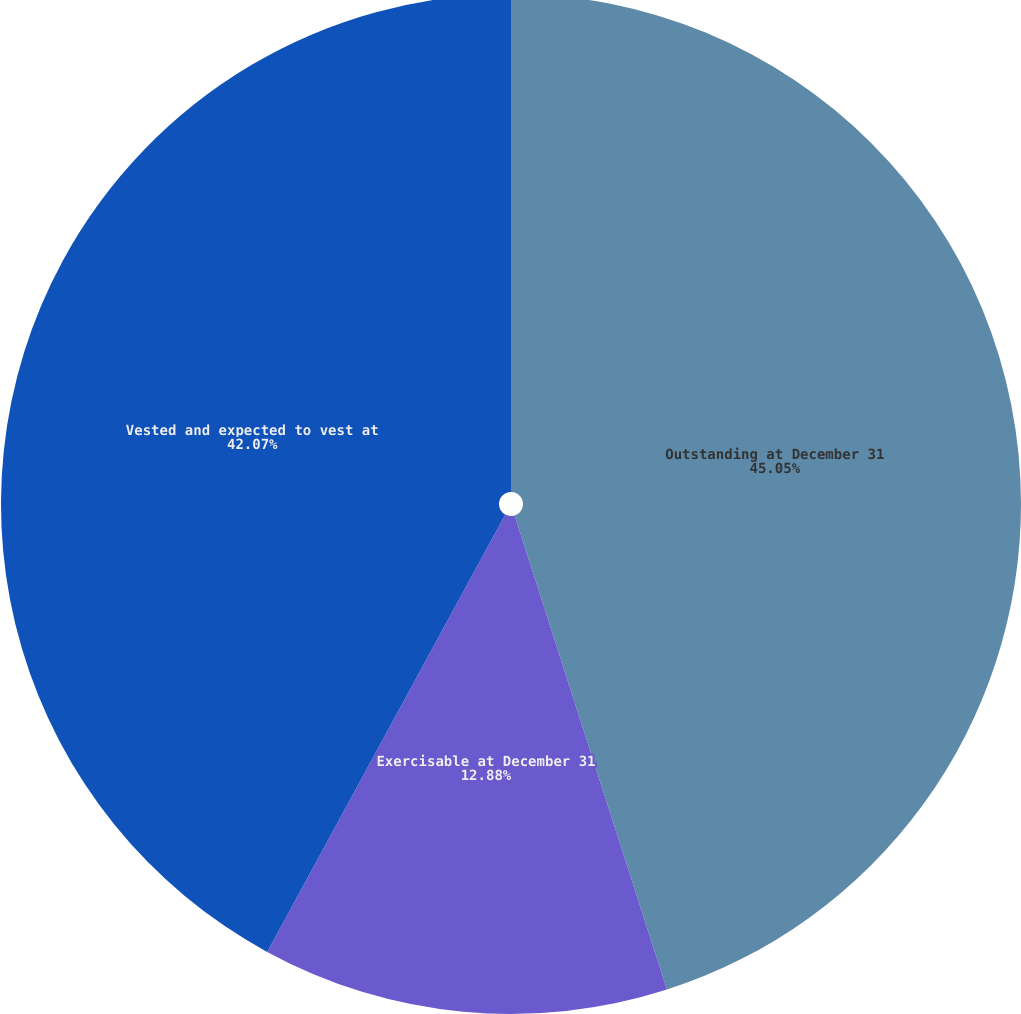<chart> <loc_0><loc_0><loc_500><loc_500><pie_chart><fcel>Outstanding at December 31<fcel>Exercisable at December 31<fcel>Vested and expected to vest at<nl><fcel>45.06%<fcel>12.88%<fcel>42.07%<nl></chart> 